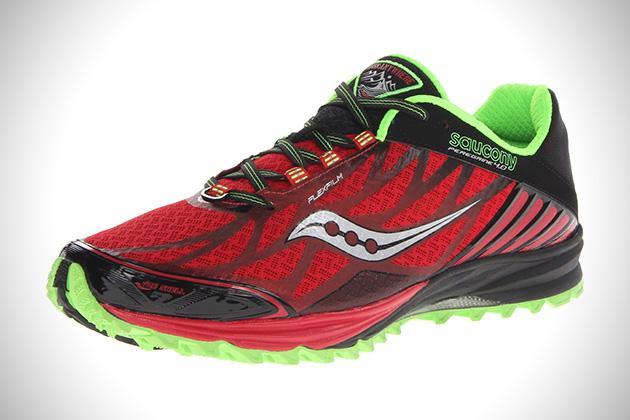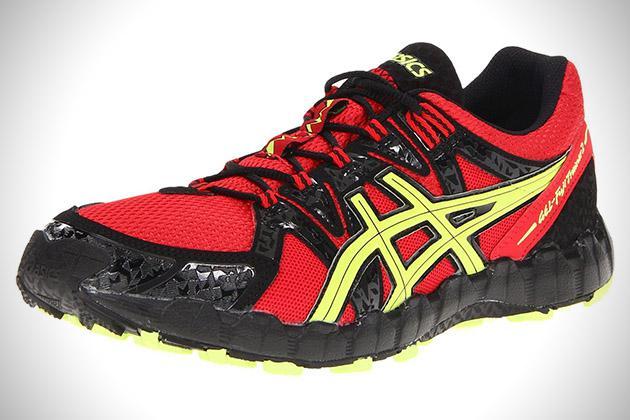The first image is the image on the left, the second image is the image on the right. Given the left and right images, does the statement "There are atleast two shoes facing right" hold true? Answer yes or no. No. The first image is the image on the left, the second image is the image on the right. Given the left and right images, does the statement "Both shoes are pointing to the right." hold true? Answer yes or no. No. 